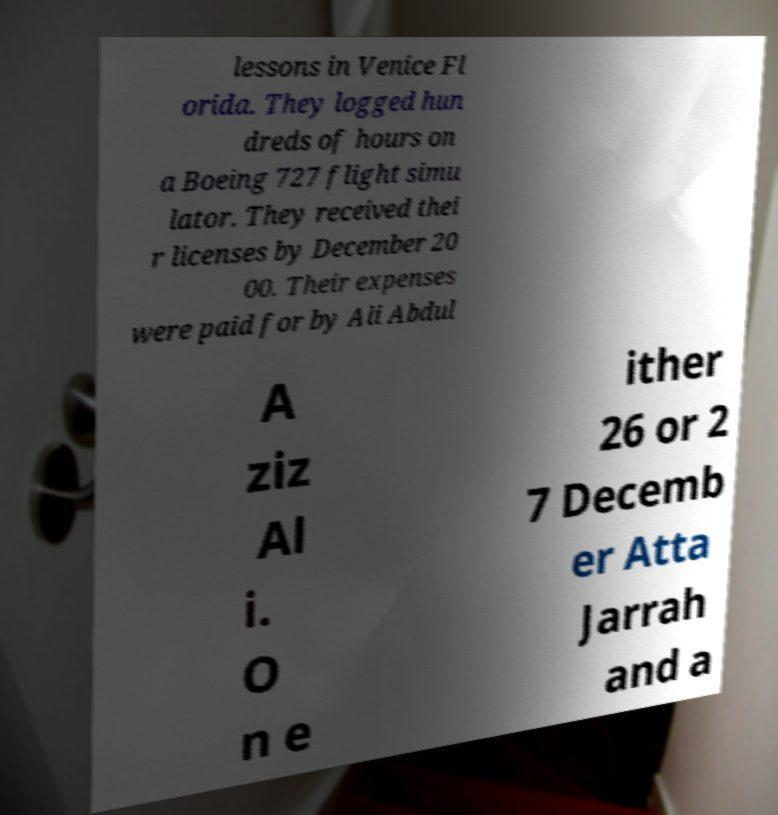Please identify and transcribe the text found in this image. lessons in Venice Fl orida. They logged hun dreds of hours on a Boeing 727 flight simu lator. They received thei r licenses by December 20 00. Their expenses were paid for by Ali Abdul A ziz Al i. O n e ither 26 or 2 7 Decemb er Atta Jarrah and a 